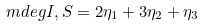<formula> <loc_0><loc_0><loc_500><loc_500>\ m d e g { I , S } = 2 \eta _ { 1 } + 3 \eta _ { 2 } + \eta _ { 3 }</formula> 